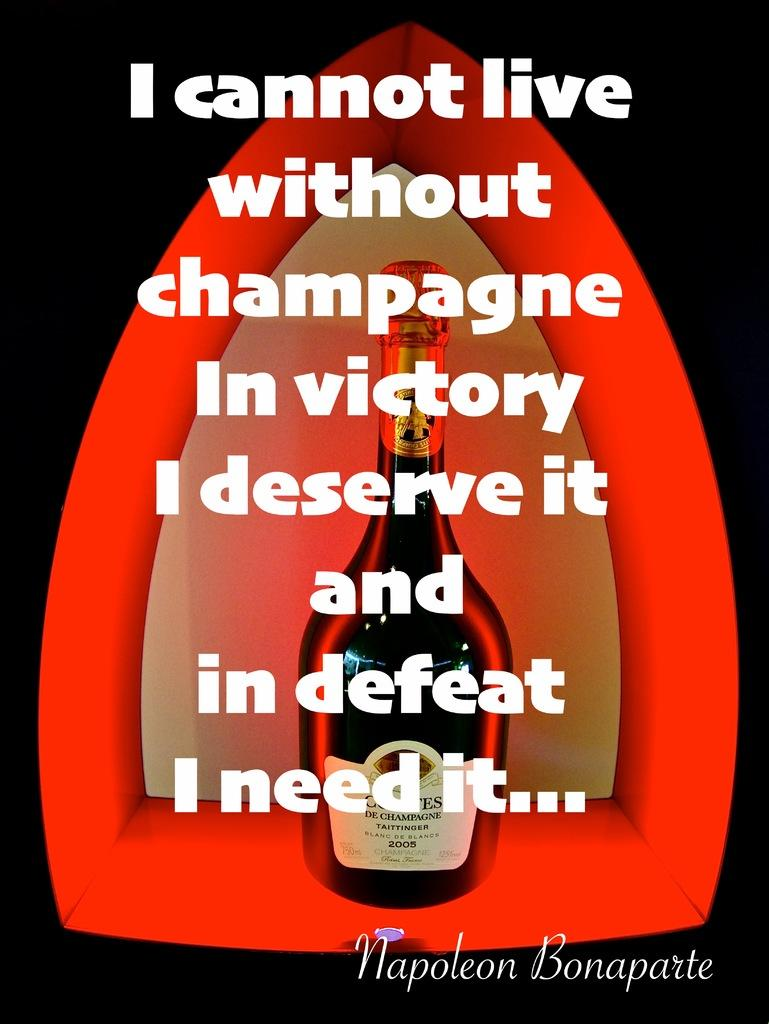<image>
Share a concise interpretation of the image provided. Famous quote with a wine bottle from Napoleon Bonaparte that says I cannot live without Champagne in victory I deserve it and in defeat I need it. 